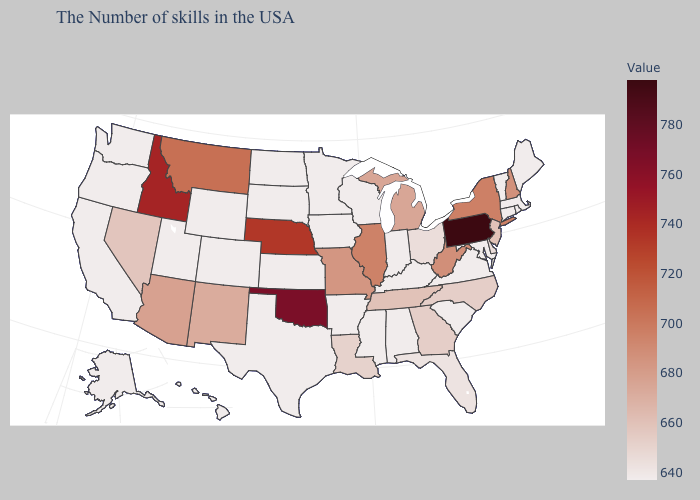Does the map have missing data?
Keep it brief. No. Does the map have missing data?
Write a very short answer. No. Which states hav the highest value in the South?
Answer briefly. Oklahoma. Among the states that border Delaware , does Maryland have the highest value?
Write a very short answer. No. Among the states that border Oregon , which have the lowest value?
Quick response, please. California, Washington. Among the states that border Massachusetts , which have the lowest value?
Quick response, please. Rhode Island, Vermont, Connecticut. Does Maine have a lower value than Idaho?
Short answer required. Yes. 